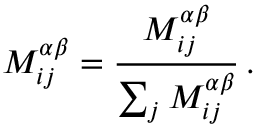<formula> <loc_0><loc_0><loc_500><loc_500>M _ { i j } ^ { \alpha \beta } = \frac { M _ { i j } ^ { \alpha \beta } } { \sum _ { j } { M _ { i j } ^ { \alpha \beta } } } \, .</formula> 